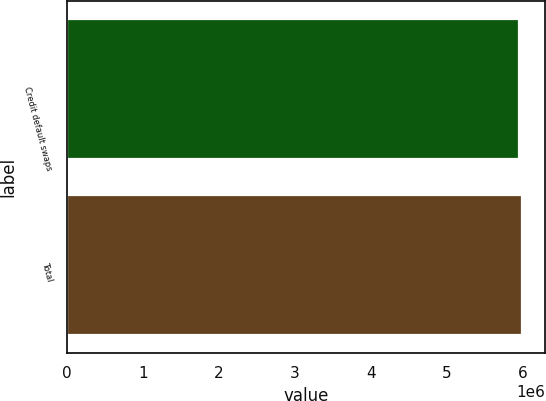Convert chart. <chart><loc_0><loc_0><loc_500><loc_500><bar_chart><fcel>Credit default swaps<fcel>Total<nl><fcel>5.94355e+06<fcel>5.99389e+06<nl></chart> 